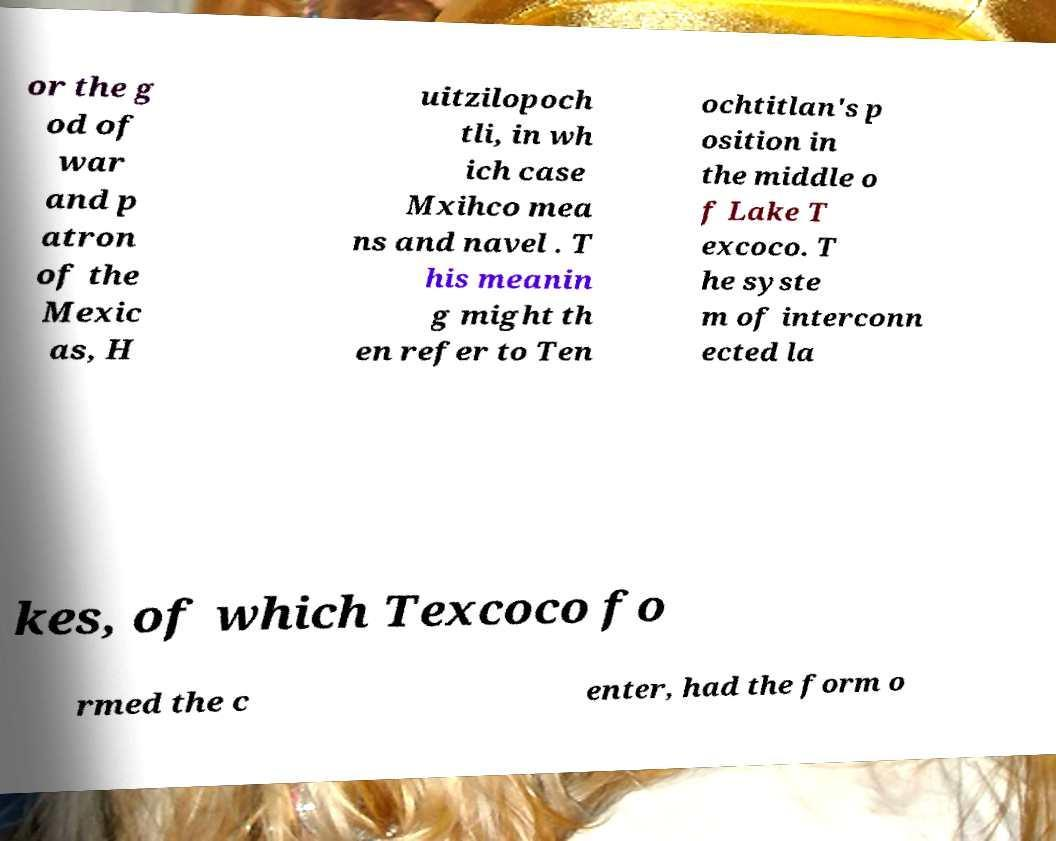I need the written content from this picture converted into text. Can you do that? or the g od of war and p atron of the Mexic as, H uitzilopoch tli, in wh ich case Mxihco mea ns and navel . T his meanin g might th en refer to Ten ochtitlan's p osition in the middle o f Lake T excoco. T he syste m of interconn ected la kes, of which Texcoco fo rmed the c enter, had the form o 